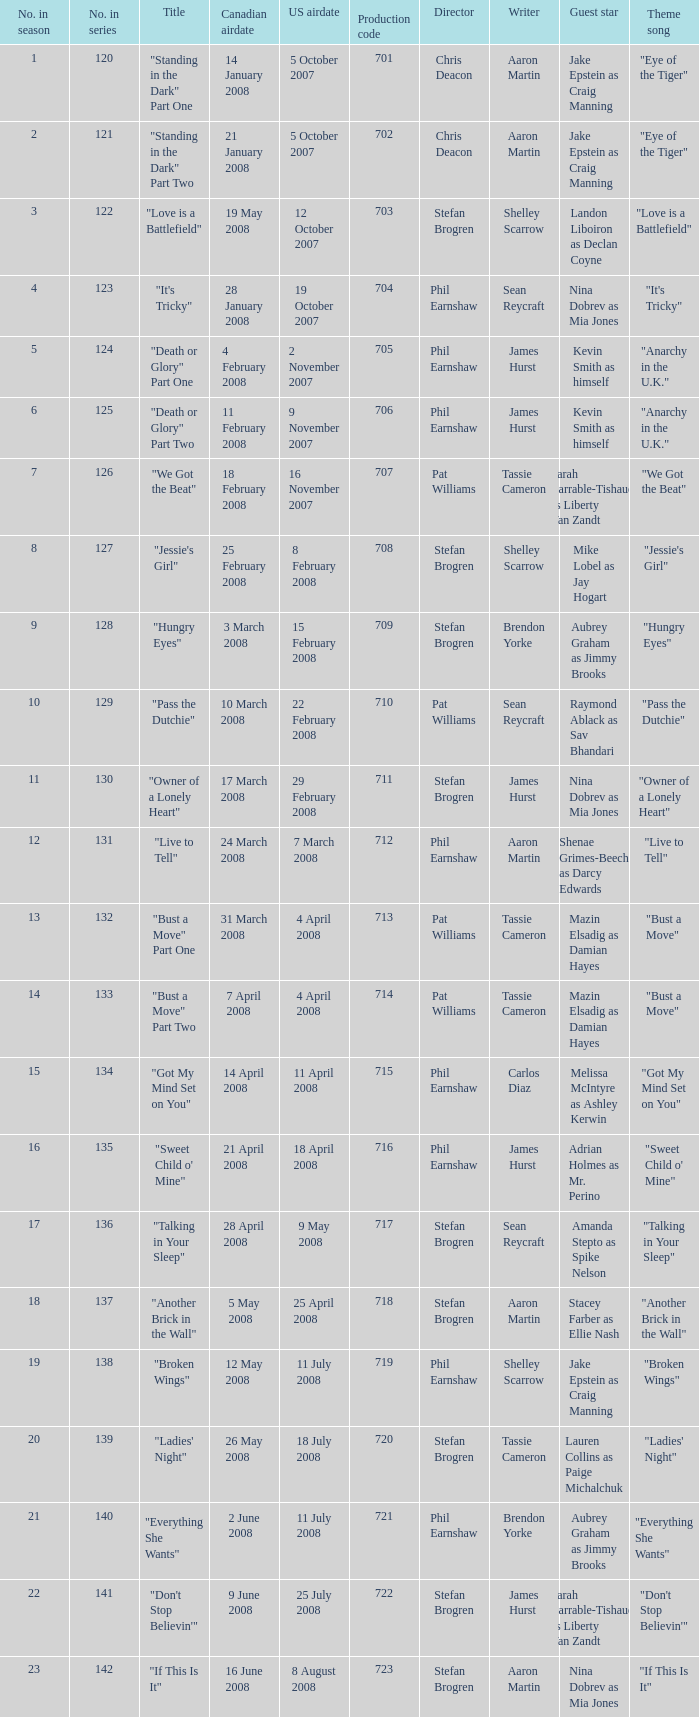For the episode(s) aired in the U.S. on 4 april 2008, what were the names? "Bust a Move" Part One, "Bust a Move" Part Two. 